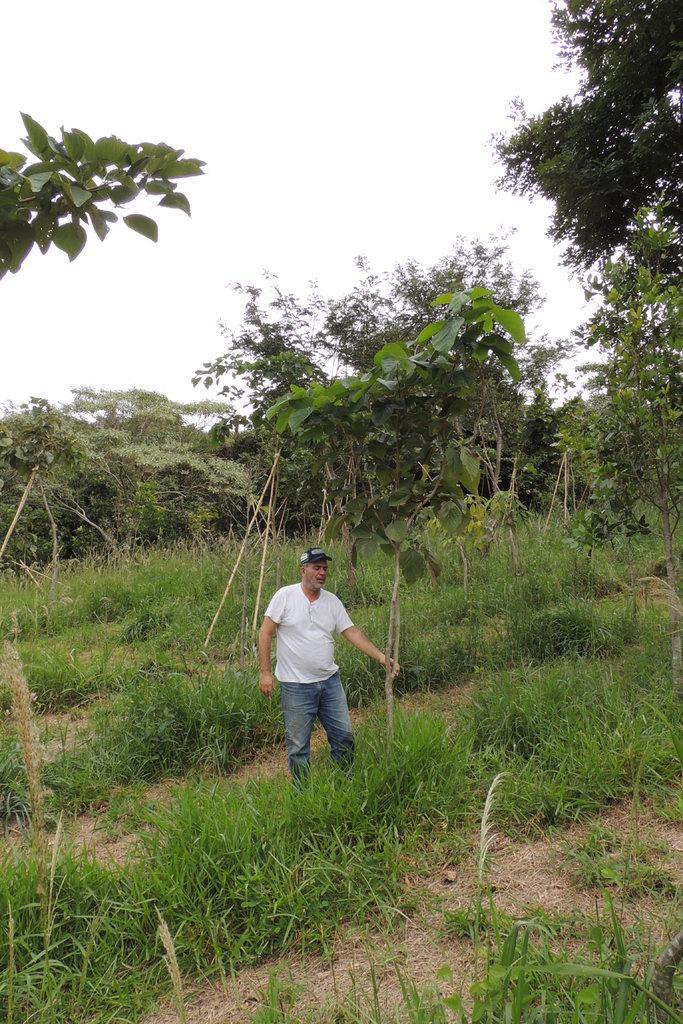How would you summarize this image in a sentence or two? In this picture we can observe a person standing on the ground wearing white color T shirt and a cap on his head. We can observe some grass on the ground. In the background there are trees and a sky. 